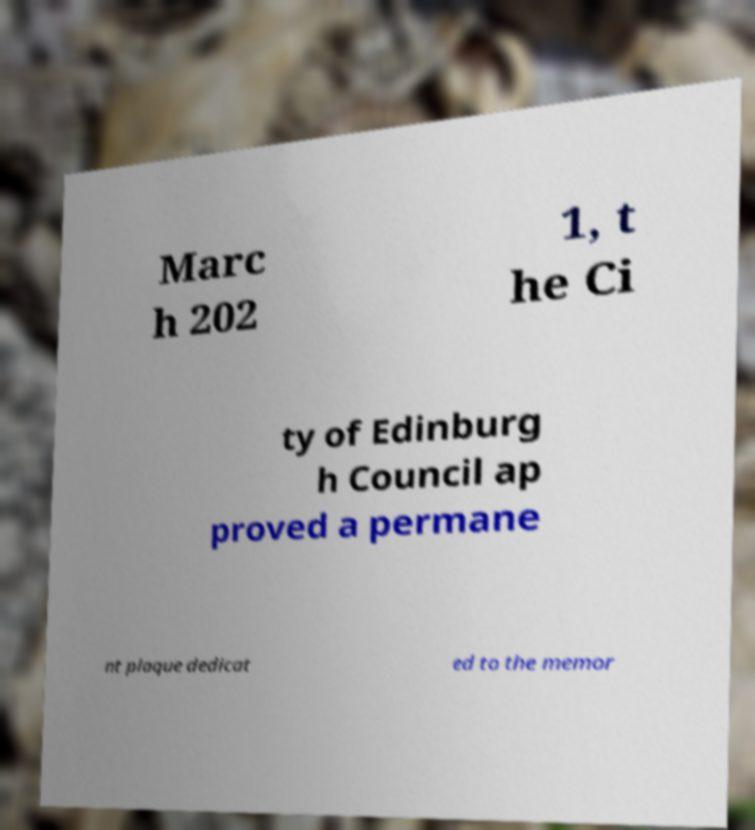Could you extract and type out the text from this image? Marc h 202 1, t he Ci ty of Edinburg h Council ap proved a permane nt plaque dedicat ed to the memor 